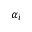<formula> <loc_0><loc_0><loc_500><loc_500>\alpha _ { i }</formula> 